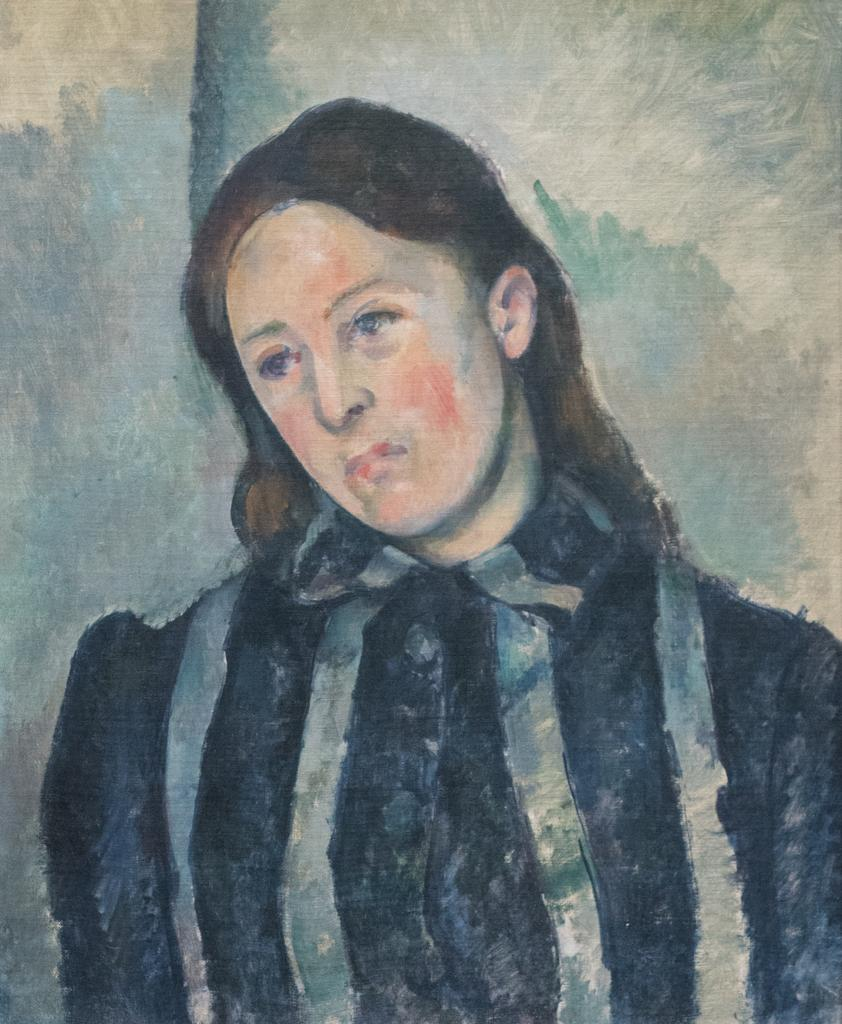What is the main subject of the image? There is a painting in the image. What does the painting depict? The painting depicts a woman. Where is the painting located in the image? The painting is on a wall. What type of disease is the woman in the painting suffering from? There is no indication of any disease in the image, as it only shows a painting of a woman. 